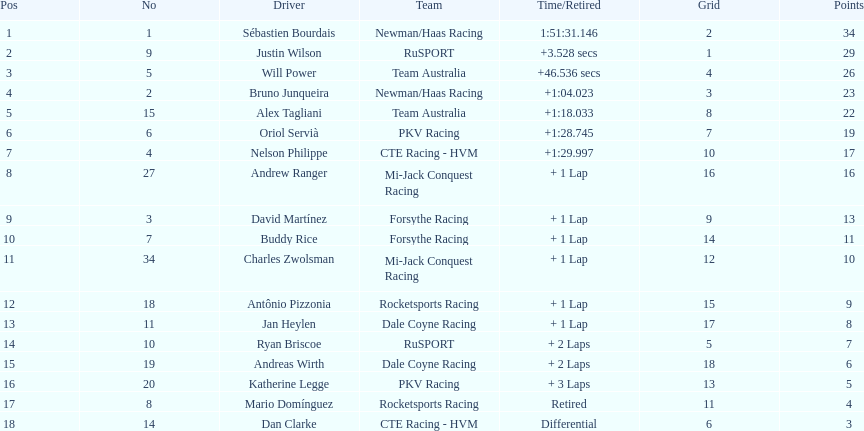What is the number of laps dan clarke completed? 7. 